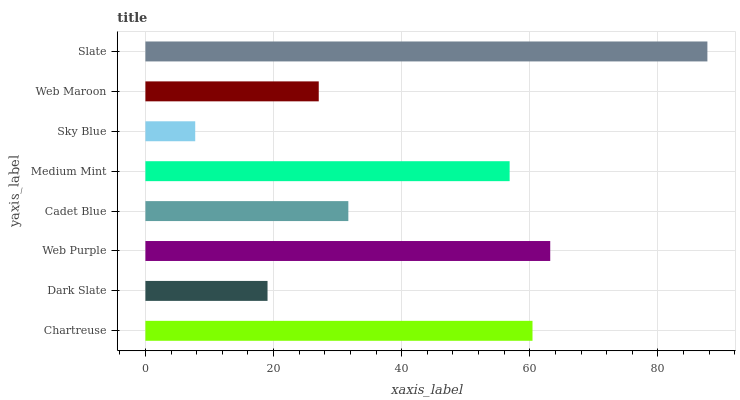Is Sky Blue the minimum?
Answer yes or no. Yes. Is Slate the maximum?
Answer yes or no. Yes. Is Dark Slate the minimum?
Answer yes or no. No. Is Dark Slate the maximum?
Answer yes or no. No. Is Chartreuse greater than Dark Slate?
Answer yes or no. Yes. Is Dark Slate less than Chartreuse?
Answer yes or no. Yes. Is Dark Slate greater than Chartreuse?
Answer yes or no. No. Is Chartreuse less than Dark Slate?
Answer yes or no. No. Is Medium Mint the high median?
Answer yes or no. Yes. Is Cadet Blue the low median?
Answer yes or no. Yes. Is Dark Slate the high median?
Answer yes or no. No. Is Chartreuse the low median?
Answer yes or no. No. 